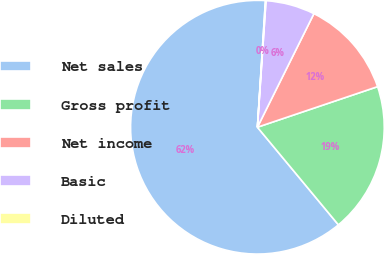<chart> <loc_0><loc_0><loc_500><loc_500><pie_chart><fcel>Net sales<fcel>Gross profit<fcel>Net income<fcel>Basic<fcel>Diluted<nl><fcel>62.03%<fcel>19.16%<fcel>12.47%<fcel>6.27%<fcel>0.07%<nl></chart> 